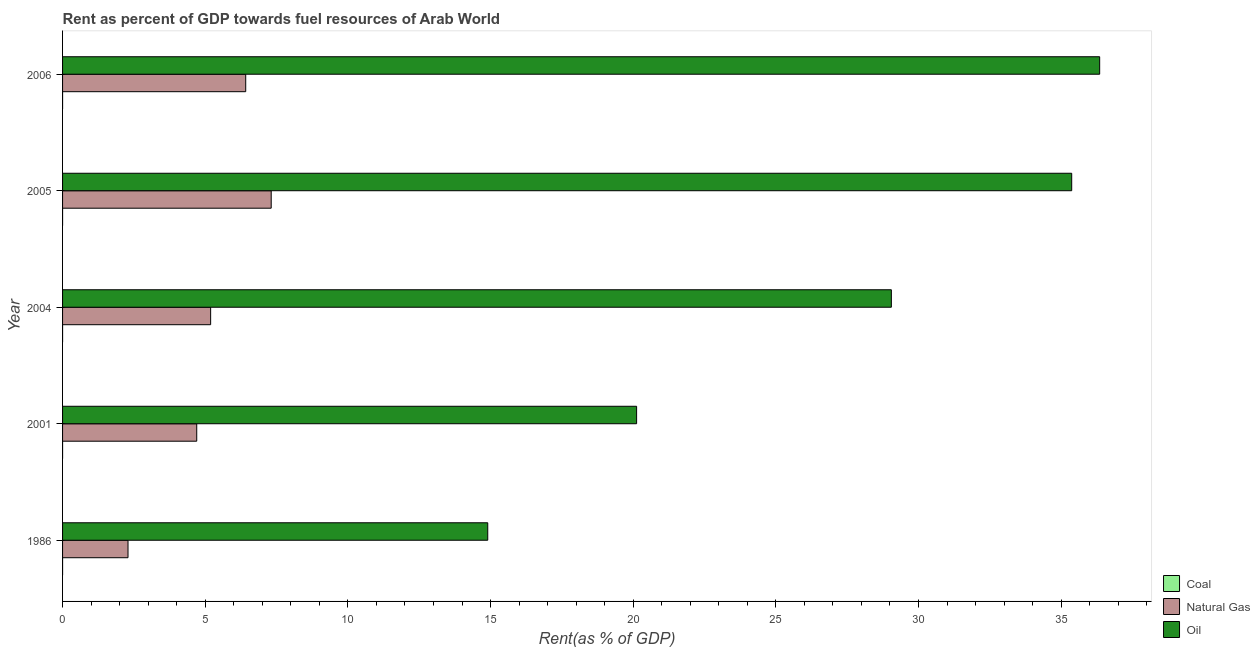How many different coloured bars are there?
Give a very brief answer. 3. How many groups of bars are there?
Make the answer very short. 5. Are the number of bars on each tick of the Y-axis equal?
Your answer should be compact. Yes. How many bars are there on the 4th tick from the top?
Your answer should be very brief. 3. What is the label of the 3rd group of bars from the top?
Provide a succinct answer. 2004. What is the rent towards oil in 2004?
Offer a terse response. 29.05. Across all years, what is the maximum rent towards coal?
Provide a succinct answer. 0. Across all years, what is the minimum rent towards natural gas?
Your response must be concise. 2.29. What is the total rent towards oil in the graph?
Your response must be concise. 135.79. What is the difference between the rent towards coal in 1986 and that in 2005?
Make the answer very short. -0. What is the difference between the rent towards natural gas in 2001 and the rent towards oil in 2004?
Offer a terse response. -24.35. What is the average rent towards natural gas per year?
Your response must be concise. 5.18. In the year 2001, what is the difference between the rent towards natural gas and rent towards oil?
Your response must be concise. -15.42. What is the ratio of the rent towards natural gas in 2004 to that in 2005?
Your answer should be very brief. 0.71. Is the difference between the rent towards coal in 1986 and 2005 greater than the difference between the rent towards oil in 1986 and 2005?
Keep it short and to the point. Yes. What is the difference between the highest and the second highest rent towards natural gas?
Offer a terse response. 0.89. In how many years, is the rent towards natural gas greater than the average rent towards natural gas taken over all years?
Your response must be concise. 3. What does the 3rd bar from the top in 1986 represents?
Keep it short and to the point. Coal. What does the 3rd bar from the bottom in 2004 represents?
Give a very brief answer. Oil. Is it the case that in every year, the sum of the rent towards coal and rent towards natural gas is greater than the rent towards oil?
Provide a succinct answer. No. How many years are there in the graph?
Keep it short and to the point. 5. Where does the legend appear in the graph?
Provide a short and direct response. Bottom right. How many legend labels are there?
Make the answer very short. 3. What is the title of the graph?
Provide a succinct answer. Rent as percent of GDP towards fuel resources of Arab World. What is the label or title of the X-axis?
Offer a terse response. Rent(as % of GDP). What is the label or title of the Y-axis?
Your answer should be very brief. Year. What is the Rent(as % of GDP) of Coal in 1986?
Your response must be concise. 1.4156492772429e-5. What is the Rent(as % of GDP) of Natural Gas in 1986?
Offer a terse response. 2.29. What is the Rent(as % of GDP) in Oil in 1986?
Make the answer very short. 14.9. What is the Rent(as % of GDP) of Coal in 2001?
Give a very brief answer. 1.52442917434249e-7. What is the Rent(as % of GDP) in Natural Gas in 2001?
Offer a terse response. 4.7. What is the Rent(as % of GDP) in Oil in 2001?
Keep it short and to the point. 20.12. What is the Rent(as % of GDP) in Coal in 2004?
Offer a very short reply. 0. What is the Rent(as % of GDP) of Natural Gas in 2004?
Your answer should be very brief. 5.19. What is the Rent(as % of GDP) of Oil in 2004?
Your answer should be very brief. 29.05. What is the Rent(as % of GDP) in Coal in 2005?
Offer a terse response. 3.046739194078689e-5. What is the Rent(as % of GDP) in Natural Gas in 2005?
Your answer should be very brief. 7.31. What is the Rent(as % of GDP) of Oil in 2005?
Your answer should be very brief. 35.37. What is the Rent(as % of GDP) in Coal in 2006?
Your answer should be compact. 3.10331580007067e-6. What is the Rent(as % of GDP) of Natural Gas in 2006?
Your answer should be very brief. 6.42. What is the Rent(as % of GDP) in Oil in 2006?
Make the answer very short. 36.35. Across all years, what is the maximum Rent(as % of GDP) of Coal?
Provide a short and direct response. 0. Across all years, what is the maximum Rent(as % of GDP) in Natural Gas?
Offer a very short reply. 7.31. Across all years, what is the maximum Rent(as % of GDP) of Oil?
Provide a succinct answer. 36.35. Across all years, what is the minimum Rent(as % of GDP) in Coal?
Your response must be concise. 1.52442917434249e-7. Across all years, what is the minimum Rent(as % of GDP) in Natural Gas?
Keep it short and to the point. 2.29. Across all years, what is the minimum Rent(as % of GDP) in Oil?
Make the answer very short. 14.9. What is the total Rent(as % of GDP) of Coal in the graph?
Keep it short and to the point. 0. What is the total Rent(as % of GDP) in Natural Gas in the graph?
Keep it short and to the point. 25.92. What is the total Rent(as % of GDP) of Oil in the graph?
Your answer should be compact. 135.79. What is the difference between the Rent(as % of GDP) of Coal in 1986 and that in 2001?
Your answer should be compact. 0. What is the difference between the Rent(as % of GDP) of Natural Gas in 1986 and that in 2001?
Your answer should be very brief. -2.41. What is the difference between the Rent(as % of GDP) in Oil in 1986 and that in 2001?
Your answer should be very brief. -5.22. What is the difference between the Rent(as % of GDP) of Coal in 1986 and that in 2004?
Keep it short and to the point. -0. What is the difference between the Rent(as % of GDP) in Natural Gas in 1986 and that in 2004?
Provide a short and direct response. -2.9. What is the difference between the Rent(as % of GDP) of Oil in 1986 and that in 2004?
Your response must be concise. -14.15. What is the difference between the Rent(as % of GDP) of Natural Gas in 1986 and that in 2005?
Offer a very short reply. -5.02. What is the difference between the Rent(as % of GDP) in Oil in 1986 and that in 2005?
Make the answer very short. -20.47. What is the difference between the Rent(as % of GDP) of Coal in 1986 and that in 2006?
Provide a succinct answer. 0. What is the difference between the Rent(as % of GDP) of Natural Gas in 1986 and that in 2006?
Your answer should be compact. -4.13. What is the difference between the Rent(as % of GDP) in Oil in 1986 and that in 2006?
Your answer should be compact. -21.45. What is the difference between the Rent(as % of GDP) of Coal in 2001 and that in 2004?
Offer a very short reply. -0. What is the difference between the Rent(as % of GDP) in Natural Gas in 2001 and that in 2004?
Provide a short and direct response. -0.49. What is the difference between the Rent(as % of GDP) in Oil in 2001 and that in 2004?
Your response must be concise. -8.93. What is the difference between the Rent(as % of GDP) in Natural Gas in 2001 and that in 2005?
Provide a short and direct response. -2.61. What is the difference between the Rent(as % of GDP) in Oil in 2001 and that in 2005?
Offer a very short reply. -15.25. What is the difference between the Rent(as % of GDP) of Natural Gas in 2001 and that in 2006?
Provide a short and direct response. -1.72. What is the difference between the Rent(as % of GDP) in Oil in 2001 and that in 2006?
Provide a succinct answer. -16.23. What is the difference between the Rent(as % of GDP) of Natural Gas in 2004 and that in 2005?
Offer a very short reply. -2.12. What is the difference between the Rent(as % of GDP) in Oil in 2004 and that in 2005?
Provide a succinct answer. -6.32. What is the difference between the Rent(as % of GDP) of Natural Gas in 2004 and that in 2006?
Your answer should be compact. -1.23. What is the difference between the Rent(as % of GDP) of Oil in 2004 and that in 2006?
Your response must be concise. -7.3. What is the difference between the Rent(as % of GDP) of Coal in 2005 and that in 2006?
Your response must be concise. 0. What is the difference between the Rent(as % of GDP) of Natural Gas in 2005 and that in 2006?
Your answer should be very brief. 0.89. What is the difference between the Rent(as % of GDP) of Oil in 2005 and that in 2006?
Your answer should be very brief. -0.98. What is the difference between the Rent(as % of GDP) of Coal in 1986 and the Rent(as % of GDP) of Natural Gas in 2001?
Provide a succinct answer. -4.7. What is the difference between the Rent(as % of GDP) of Coal in 1986 and the Rent(as % of GDP) of Oil in 2001?
Provide a short and direct response. -20.12. What is the difference between the Rent(as % of GDP) of Natural Gas in 1986 and the Rent(as % of GDP) of Oil in 2001?
Provide a succinct answer. -17.83. What is the difference between the Rent(as % of GDP) of Coal in 1986 and the Rent(as % of GDP) of Natural Gas in 2004?
Provide a succinct answer. -5.19. What is the difference between the Rent(as % of GDP) in Coal in 1986 and the Rent(as % of GDP) in Oil in 2004?
Your answer should be compact. -29.05. What is the difference between the Rent(as % of GDP) of Natural Gas in 1986 and the Rent(as % of GDP) of Oil in 2004?
Offer a terse response. -26.75. What is the difference between the Rent(as % of GDP) in Coal in 1986 and the Rent(as % of GDP) in Natural Gas in 2005?
Your answer should be compact. -7.31. What is the difference between the Rent(as % of GDP) in Coal in 1986 and the Rent(as % of GDP) in Oil in 2005?
Your response must be concise. -35.37. What is the difference between the Rent(as % of GDP) in Natural Gas in 1986 and the Rent(as % of GDP) in Oil in 2005?
Your response must be concise. -33.08. What is the difference between the Rent(as % of GDP) of Coal in 1986 and the Rent(as % of GDP) of Natural Gas in 2006?
Give a very brief answer. -6.42. What is the difference between the Rent(as % of GDP) of Coal in 1986 and the Rent(as % of GDP) of Oil in 2006?
Your answer should be compact. -36.35. What is the difference between the Rent(as % of GDP) in Natural Gas in 1986 and the Rent(as % of GDP) in Oil in 2006?
Provide a short and direct response. -34.06. What is the difference between the Rent(as % of GDP) in Coal in 2001 and the Rent(as % of GDP) in Natural Gas in 2004?
Ensure brevity in your answer.  -5.19. What is the difference between the Rent(as % of GDP) in Coal in 2001 and the Rent(as % of GDP) in Oil in 2004?
Keep it short and to the point. -29.05. What is the difference between the Rent(as % of GDP) in Natural Gas in 2001 and the Rent(as % of GDP) in Oil in 2004?
Make the answer very short. -24.35. What is the difference between the Rent(as % of GDP) of Coal in 2001 and the Rent(as % of GDP) of Natural Gas in 2005?
Provide a succinct answer. -7.31. What is the difference between the Rent(as % of GDP) in Coal in 2001 and the Rent(as % of GDP) in Oil in 2005?
Ensure brevity in your answer.  -35.37. What is the difference between the Rent(as % of GDP) in Natural Gas in 2001 and the Rent(as % of GDP) in Oil in 2005?
Offer a terse response. -30.67. What is the difference between the Rent(as % of GDP) of Coal in 2001 and the Rent(as % of GDP) of Natural Gas in 2006?
Make the answer very short. -6.42. What is the difference between the Rent(as % of GDP) in Coal in 2001 and the Rent(as % of GDP) in Oil in 2006?
Make the answer very short. -36.35. What is the difference between the Rent(as % of GDP) of Natural Gas in 2001 and the Rent(as % of GDP) of Oil in 2006?
Provide a succinct answer. -31.65. What is the difference between the Rent(as % of GDP) of Coal in 2004 and the Rent(as % of GDP) of Natural Gas in 2005?
Offer a very short reply. -7.31. What is the difference between the Rent(as % of GDP) in Coal in 2004 and the Rent(as % of GDP) in Oil in 2005?
Keep it short and to the point. -35.37. What is the difference between the Rent(as % of GDP) in Natural Gas in 2004 and the Rent(as % of GDP) in Oil in 2005?
Make the answer very short. -30.18. What is the difference between the Rent(as % of GDP) of Coal in 2004 and the Rent(as % of GDP) of Natural Gas in 2006?
Offer a very short reply. -6.42. What is the difference between the Rent(as % of GDP) of Coal in 2004 and the Rent(as % of GDP) of Oil in 2006?
Provide a short and direct response. -36.35. What is the difference between the Rent(as % of GDP) in Natural Gas in 2004 and the Rent(as % of GDP) in Oil in 2006?
Ensure brevity in your answer.  -31.16. What is the difference between the Rent(as % of GDP) in Coal in 2005 and the Rent(as % of GDP) in Natural Gas in 2006?
Provide a succinct answer. -6.42. What is the difference between the Rent(as % of GDP) of Coal in 2005 and the Rent(as % of GDP) of Oil in 2006?
Make the answer very short. -36.35. What is the difference between the Rent(as % of GDP) in Natural Gas in 2005 and the Rent(as % of GDP) in Oil in 2006?
Your answer should be compact. -29.04. What is the average Rent(as % of GDP) of Coal per year?
Provide a short and direct response. 0. What is the average Rent(as % of GDP) of Natural Gas per year?
Your answer should be very brief. 5.18. What is the average Rent(as % of GDP) of Oil per year?
Give a very brief answer. 27.16. In the year 1986, what is the difference between the Rent(as % of GDP) in Coal and Rent(as % of GDP) in Natural Gas?
Your answer should be very brief. -2.29. In the year 1986, what is the difference between the Rent(as % of GDP) in Coal and Rent(as % of GDP) in Oil?
Ensure brevity in your answer.  -14.9. In the year 1986, what is the difference between the Rent(as % of GDP) in Natural Gas and Rent(as % of GDP) in Oil?
Ensure brevity in your answer.  -12.61. In the year 2001, what is the difference between the Rent(as % of GDP) in Coal and Rent(as % of GDP) in Natural Gas?
Your answer should be very brief. -4.7. In the year 2001, what is the difference between the Rent(as % of GDP) in Coal and Rent(as % of GDP) in Oil?
Offer a very short reply. -20.12. In the year 2001, what is the difference between the Rent(as % of GDP) of Natural Gas and Rent(as % of GDP) of Oil?
Ensure brevity in your answer.  -15.42. In the year 2004, what is the difference between the Rent(as % of GDP) of Coal and Rent(as % of GDP) of Natural Gas?
Your response must be concise. -5.19. In the year 2004, what is the difference between the Rent(as % of GDP) of Coal and Rent(as % of GDP) of Oil?
Give a very brief answer. -29.05. In the year 2004, what is the difference between the Rent(as % of GDP) in Natural Gas and Rent(as % of GDP) in Oil?
Keep it short and to the point. -23.86. In the year 2005, what is the difference between the Rent(as % of GDP) in Coal and Rent(as % of GDP) in Natural Gas?
Your answer should be very brief. -7.31. In the year 2005, what is the difference between the Rent(as % of GDP) of Coal and Rent(as % of GDP) of Oil?
Offer a terse response. -35.37. In the year 2005, what is the difference between the Rent(as % of GDP) in Natural Gas and Rent(as % of GDP) in Oil?
Keep it short and to the point. -28.06. In the year 2006, what is the difference between the Rent(as % of GDP) in Coal and Rent(as % of GDP) in Natural Gas?
Your response must be concise. -6.42. In the year 2006, what is the difference between the Rent(as % of GDP) in Coal and Rent(as % of GDP) in Oil?
Your response must be concise. -36.35. In the year 2006, what is the difference between the Rent(as % of GDP) of Natural Gas and Rent(as % of GDP) of Oil?
Provide a short and direct response. -29.93. What is the ratio of the Rent(as % of GDP) in Coal in 1986 to that in 2001?
Give a very brief answer. 92.86. What is the ratio of the Rent(as % of GDP) of Natural Gas in 1986 to that in 2001?
Ensure brevity in your answer.  0.49. What is the ratio of the Rent(as % of GDP) in Oil in 1986 to that in 2001?
Give a very brief answer. 0.74. What is the ratio of the Rent(as % of GDP) of Coal in 1986 to that in 2004?
Keep it short and to the point. 0.13. What is the ratio of the Rent(as % of GDP) of Natural Gas in 1986 to that in 2004?
Offer a terse response. 0.44. What is the ratio of the Rent(as % of GDP) of Oil in 1986 to that in 2004?
Keep it short and to the point. 0.51. What is the ratio of the Rent(as % of GDP) in Coal in 1986 to that in 2005?
Provide a short and direct response. 0.46. What is the ratio of the Rent(as % of GDP) of Natural Gas in 1986 to that in 2005?
Keep it short and to the point. 0.31. What is the ratio of the Rent(as % of GDP) of Oil in 1986 to that in 2005?
Offer a terse response. 0.42. What is the ratio of the Rent(as % of GDP) of Coal in 1986 to that in 2006?
Give a very brief answer. 4.56. What is the ratio of the Rent(as % of GDP) in Natural Gas in 1986 to that in 2006?
Keep it short and to the point. 0.36. What is the ratio of the Rent(as % of GDP) in Oil in 1986 to that in 2006?
Your answer should be very brief. 0.41. What is the ratio of the Rent(as % of GDP) of Coal in 2001 to that in 2004?
Offer a terse response. 0. What is the ratio of the Rent(as % of GDP) of Natural Gas in 2001 to that in 2004?
Your response must be concise. 0.91. What is the ratio of the Rent(as % of GDP) in Oil in 2001 to that in 2004?
Your answer should be compact. 0.69. What is the ratio of the Rent(as % of GDP) in Coal in 2001 to that in 2005?
Keep it short and to the point. 0.01. What is the ratio of the Rent(as % of GDP) of Natural Gas in 2001 to that in 2005?
Ensure brevity in your answer.  0.64. What is the ratio of the Rent(as % of GDP) in Oil in 2001 to that in 2005?
Ensure brevity in your answer.  0.57. What is the ratio of the Rent(as % of GDP) in Coal in 2001 to that in 2006?
Provide a short and direct response. 0.05. What is the ratio of the Rent(as % of GDP) in Natural Gas in 2001 to that in 2006?
Your response must be concise. 0.73. What is the ratio of the Rent(as % of GDP) of Oil in 2001 to that in 2006?
Provide a short and direct response. 0.55. What is the ratio of the Rent(as % of GDP) in Coal in 2004 to that in 2005?
Offer a terse response. 3.53. What is the ratio of the Rent(as % of GDP) in Natural Gas in 2004 to that in 2005?
Your answer should be compact. 0.71. What is the ratio of the Rent(as % of GDP) of Oil in 2004 to that in 2005?
Your answer should be very brief. 0.82. What is the ratio of the Rent(as % of GDP) of Coal in 2004 to that in 2006?
Your answer should be compact. 34.69. What is the ratio of the Rent(as % of GDP) in Natural Gas in 2004 to that in 2006?
Keep it short and to the point. 0.81. What is the ratio of the Rent(as % of GDP) in Oil in 2004 to that in 2006?
Keep it short and to the point. 0.8. What is the ratio of the Rent(as % of GDP) of Coal in 2005 to that in 2006?
Your response must be concise. 9.82. What is the ratio of the Rent(as % of GDP) of Natural Gas in 2005 to that in 2006?
Provide a short and direct response. 1.14. What is the ratio of the Rent(as % of GDP) in Oil in 2005 to that in 2006?
Your answer should be very brief. 0.97. What is the difference between the highest and the second highest Rent(as % of GDP) of Coal?
Your answer should be compact. 0. What is the difference between the highest and the second highest Rent(as % of GDP) in Natural Gas?
Keep it short and to the point. 0.89. What is the difference between the highest and the second highest Rent(as % of GDP) of Oil?
Offer a terse response. 0.98. What is the difference between the highest and the lowest Rent(as % of GDP) in Coal?
Offer a terse response. 0. What is the difference between the highest and the lowest Rent(as % of GDP) in Natural Gas?
Provide a short and direct response. 5.02. What is the difference between the highest and the lowest Rent(as % of GDP) of Oil?
Provide a succinct answer. 21.45. 